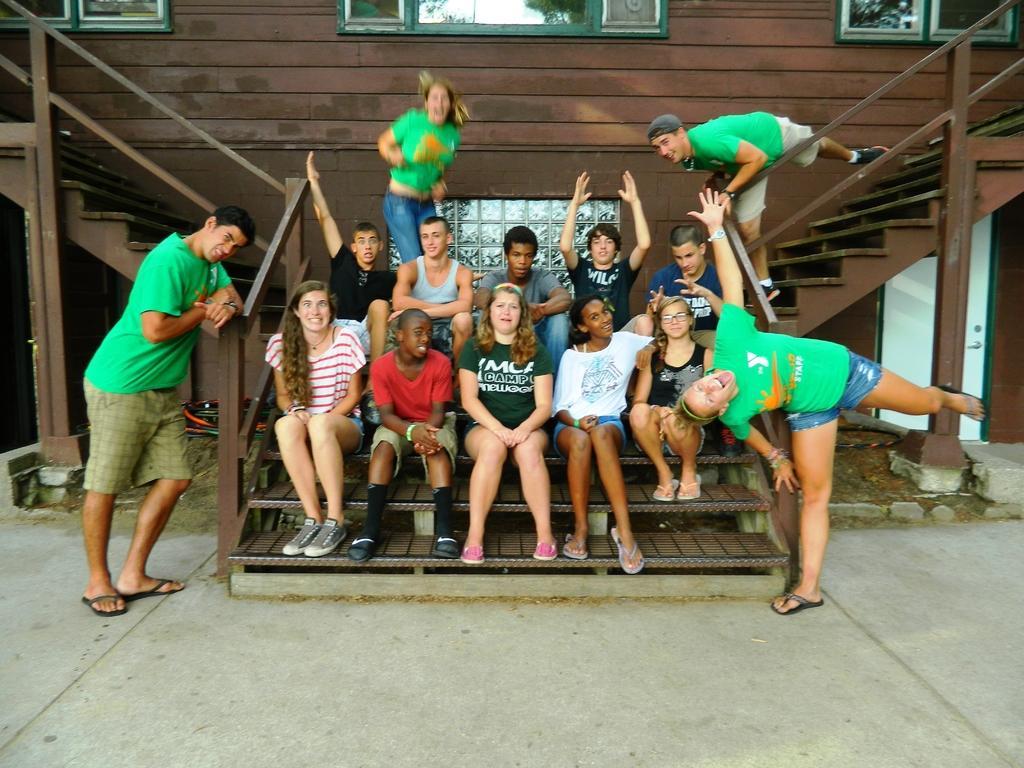How would you summarize this image in a sentence or two? In this picture we can see two people standing on the ground, some people sitting on the steps and in the background we can see the wall, door, windows and some objects. 